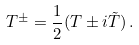<formula> <loc_0><loc_0><loc_500><loc_500>T ^ { \pm } = \frac { 1 } { 2 } ( T \pm i \tilde { T } ) \, .</formula> 